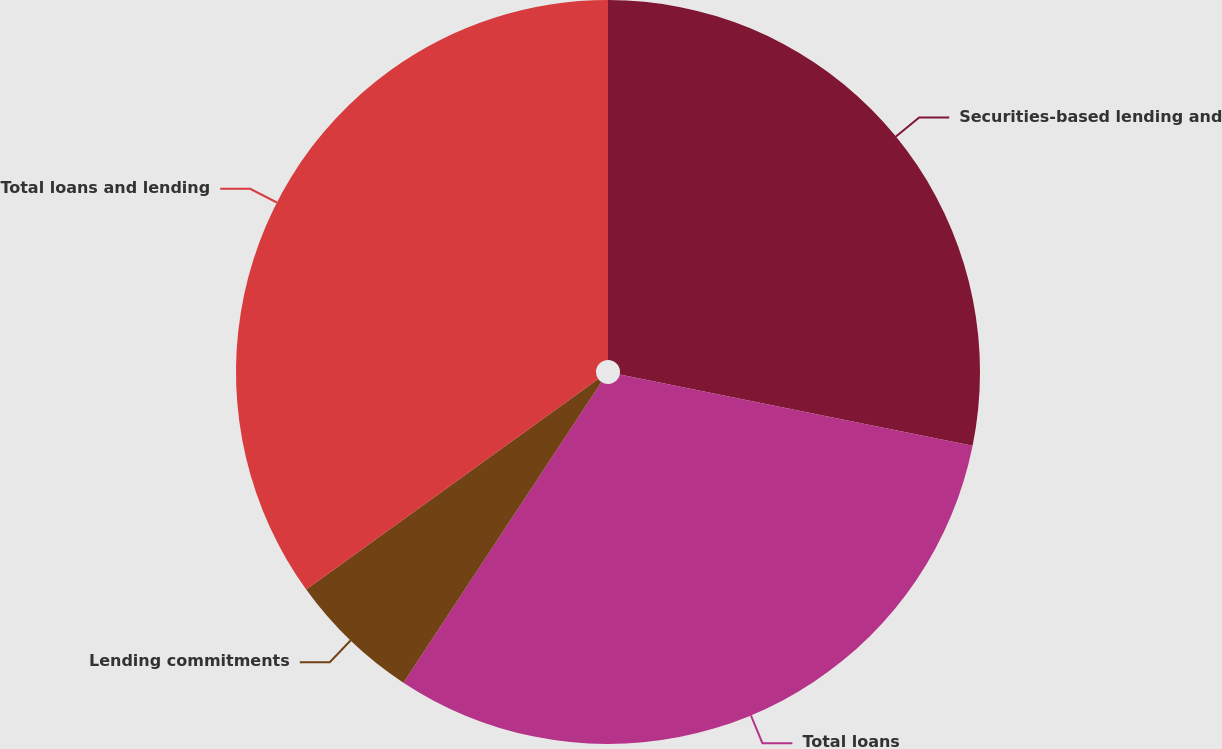<chart> <loc_0><loc_0><loc_500><loc_500><pie_chart><fcel>Securities-based lending and<fcel>Total loans<fcel>Lending commitments<fcel>Total loans and lending<nl><fcel>28.18%<fcel>31.09%<fcel>5.79%<fcel>34.94%<nl></chart> 